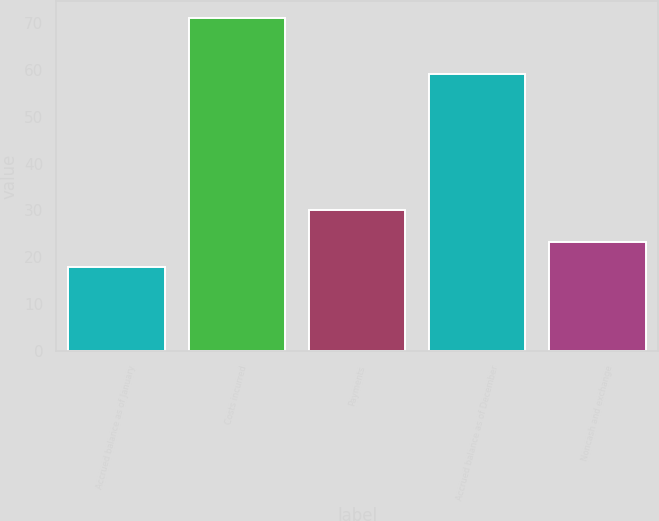<chart> <loc_0><loc_0><loc_500><loc_500><bar_chart><fcel>Accrued balance as of January<fcel>Costs incurred<fcel>Payments<fcel>Accrued balance as of December<fcel>Noncash and exchange<nl><fcel>18<fcel>71<fcel>30<fcel>59<fcel>23.3<nl></chart> 